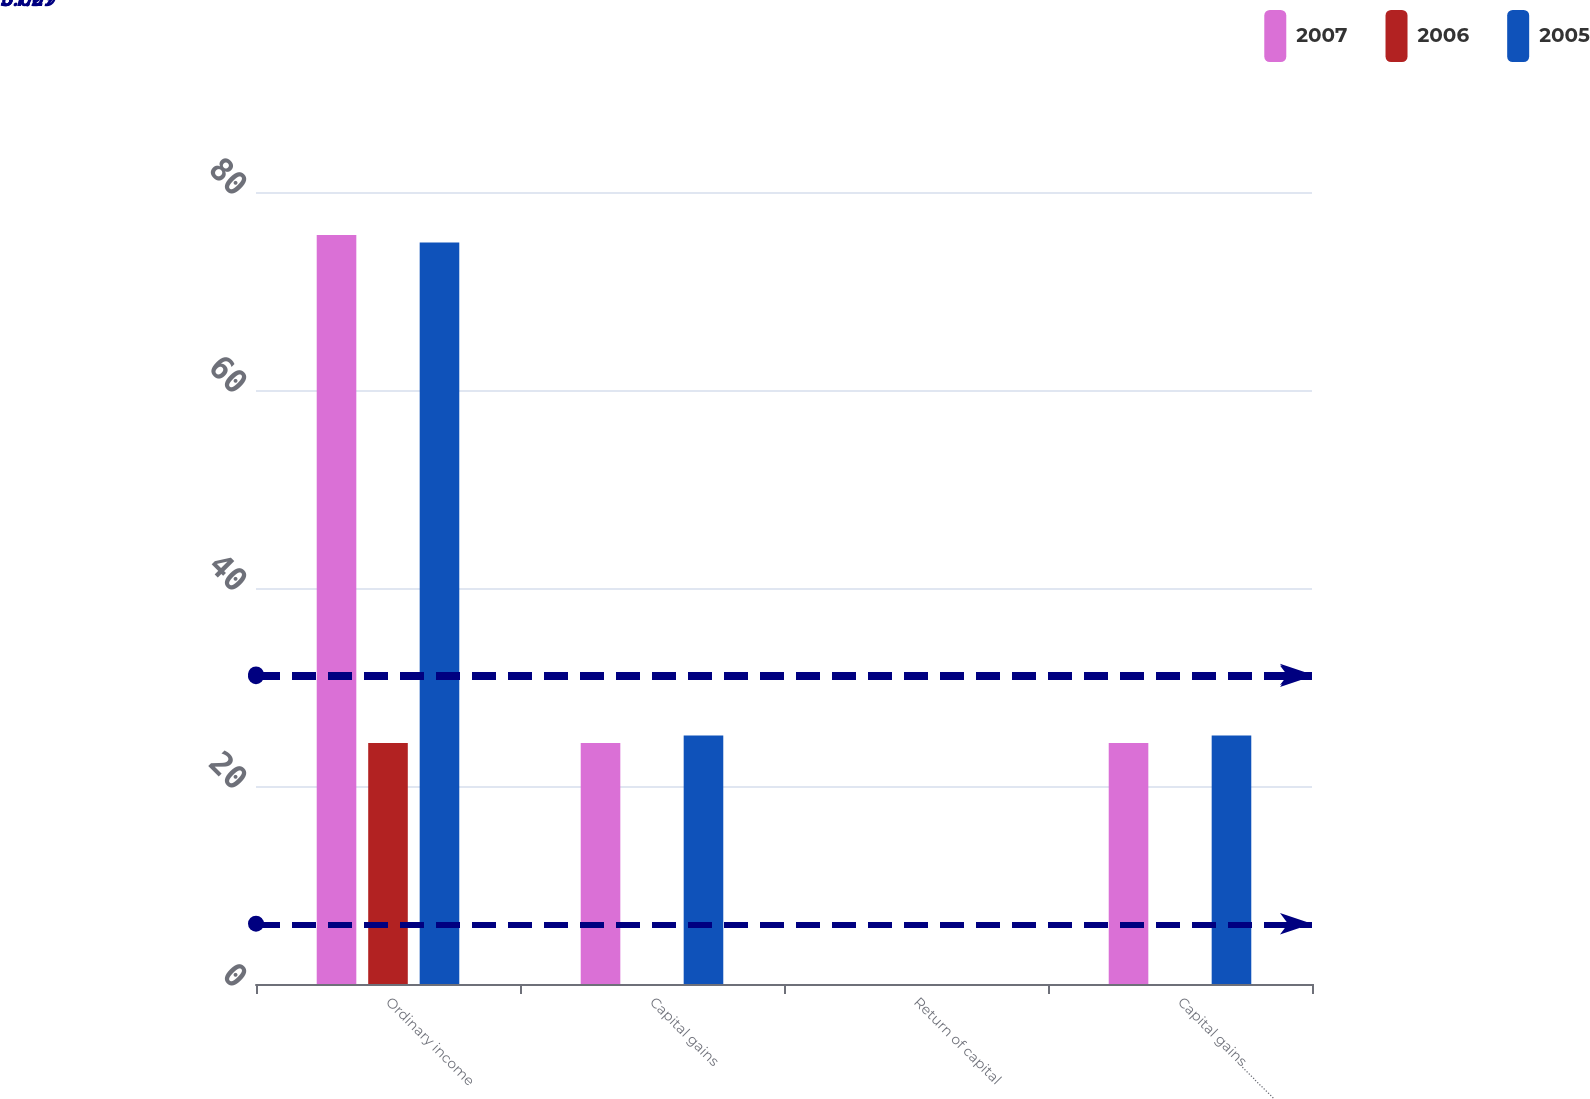<chart> <loc_0><loc_0><loc_500><loc_500><stacked_bar_chart><ecel><fcel>Ordinary income<fcel>Capital gains<fcel>Return of capital<fcel>Capital gains……………<nl><fcel>2007<fcel>75.65<fcel>24.35<fcel>0<fcel>24.35<nl><fcel>2006<fcel>24.35<fcel>0<fcel>0<fcel>0<nl><fcel>2005<fcel>74.91<fcel>25.09<fcel>0<fcel>25.09<nl></chart> 